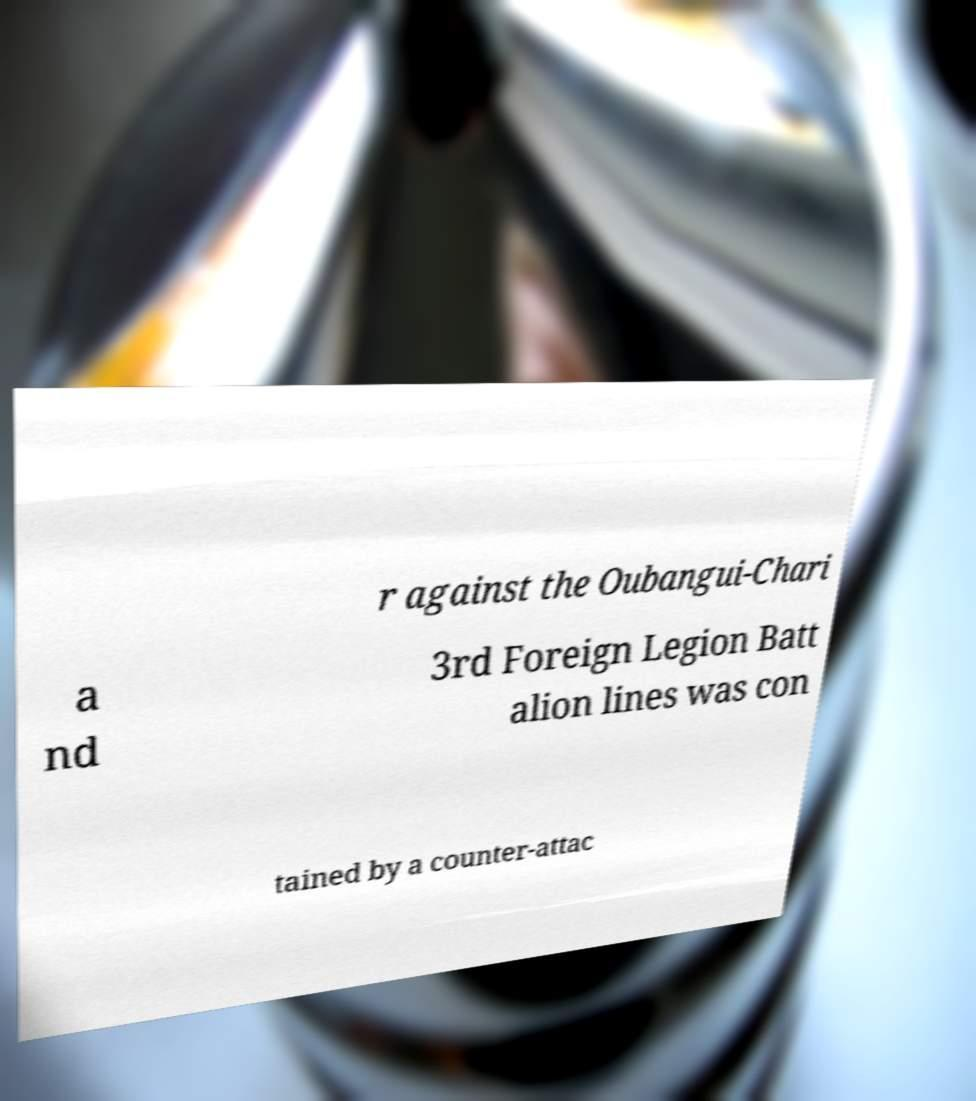Can you read and provide the text displayed in the image?This photo seems to have some interesting text. Can you extract and type it out for me? r against the Oubangui-Chari a nd 3rd Foreign Legion Batt alion lines was con tained by a counter-attac 